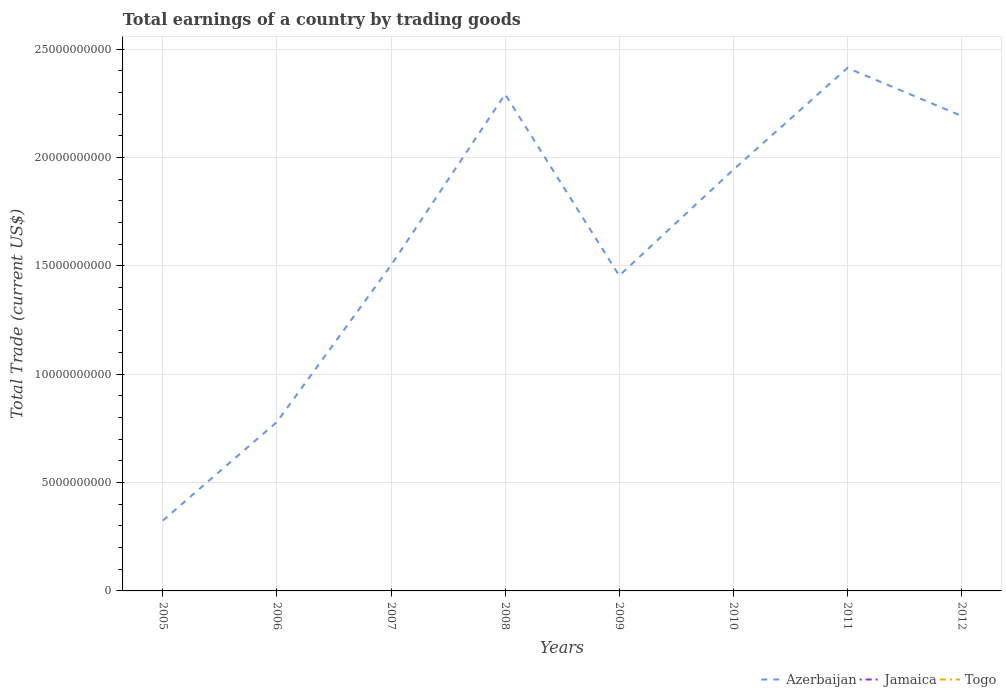How many different coloured lines are there?
Give a very brief answer. 1. Across all years, what is the maximum total earnings in Azerbaijan?
Make the answer very short. 3.25e+09. What is the total total earnings in Azerbaijan in the graph?
Keep it short and to the point. -6.75e+09. What is the difference between the highest and the second highest total earnings in Azerbaijan?
Give a very brief answer. 2.09e+1. Is the total earnings in Jamaica strictly greater than the total earnings in Azerbaijan over the years?
Your answer should be compact. Yes. How many years are there in the graph?
Ensure brevity in your answer.  8. What is the difference between two consecutive major ticks on the Y-axis?
Offer a terse response. 5.00e+09. Are the values on the major ticks of Y-axis written in scientific E-notation?
Your answer should be compact. No. Does the graph contain any zero values?
Keep it short and to the point. Yes. Where does the legend appear in the graph?
Offer a very short reply. Bottom right. How are the legend labels stacked?
Keep it short and to the point. Horizontal. What is the title of the graph?
Your response must be concise. Total earnings of a country by trading goods. What is the label or title of the Y-axis?
Your response must be concise. Total Trade (current US$). What is the Total Trade (current US$) of Azerbaijan in 2005?
Give a very brief answer. 3.25e+09. What is the Total Trade (current US$) of Jamaica in 2005?
Give a very brief answer. 0. What is the Total Trade (current US$) in Azerbaijan in 2006?
Make the answer very short. 7.80e+09. What is the Total Trade (current US$) of Jamaica in 2006?
Make the answer very short. 0. What is the Total Trade (current US$) in Azerbaijan in 2007?
Offer a terse response. 1.50e+1. What is the Total Trade (current US$) in Jamaica in 2007?
Your answer should be compact. 0. What is the Total Trade (current US$) of Azerbaijan in 2008?
Offer a very short reply. 2.29e+1. What is the Total Trade (current US$) of Togo in 2008?
Provide a short and direct response. 0. What is the Total Trade (current US$) of Azerbaijan in 2009?
Make the answer very short. 1.45e+1. What is the Total Trade (current US$) of Togo in 2009?
Offer a terse response. 0. What is the Total Trade (current US$) in Azerbaijan in 2010?
Your response must be concise. 1.94e+1. What is the Total Trade (current US$) in Togo in 2010?
Your answer should be compact. 0. What is the Total Trade (current US$) of Azerbaijan in 2011?
Your response must be concise. 2.41e+1. What is the Total Trade (current US$) in Togo in 2011?
Your response must be concise. 0. What is the Total Trade (current US$) in Azerbaijan in 2012?
Your answer should be very brief. 2.19e+1. What is the Total Trade (current US$) in Jamaica in 2012?
Your response must be concise. 0. Across all years, what is the maximum Total Trade (current US$) in Azerbaijan?
Offer a terse response. 2.41e+1. Across all years, what is the minimum Total Trade (current US$) in Azerbaijan?
Your answer should be compact. 3.25e+09. What is the total Total Trade (current US$) in Azerbaijan in the graph?
Give a very brief answer. 1.29e+11. What is the difference between the Total Trade (current US$) in Azerbaijan in 2005 and that in 2006?
Make the answer very short. -4.55e+09. What is the difference between the Total Trade (current US$) of Azerbaijan in 2005 and that in 2007?
Your response must be concise. -1.18e+1. What is the difference between the Total Trade (current US$) of Azerbaijan in 2005 and that in 2008?
Your answer should be compact. -1.97e+1. What is the difference between the Total Trade (current US$) in Azerbaijan in 2005 and that in 2009?
Ensure brevity in your answer.  -1.13e+1. What is the difference between the Total Trade (current US$) in Azerbaijan in 2005 and that in 2010?
Provide a succinct answer. -1.62e+1. What is the difference between the Total Trade (current US$) of Azerbaijan in 2005 and that in 2011?
Your answer should be compact. -2.09e+1. What is the difference between the Total Trade (current US$) in Azerbaijan in 2005 and that in 2012?
Your response must be concise. -1.87e+1. What is the difference between the Total Trade (current US$) in Azerbaijan in 2006 and that in 2007?
Ensure brevity in your answer.  -7.23e+09. What is the difference between the Total Trade (current US$) of Azerbaijan in 2006 and that in 2008?
Provide a succinct answer. -1.51e+1. What is the difference between the Total Trade (current US$) of Azerbaijan in 2006 and that in 2009?
Provide a short and direct response. -6.75e+09. What is the difference between the Total Trade (current US$) of Azerbaijan in 2006 and that in 2010?
Keep it short and to the point. -1.16e+1. What is the difference between the Total Trade (current US$) of Azerbaijan in 2006 and that in 2011?
Your answer should be very brief. -1.63e+1. What is the difference between the Total Trade (current US$) in Azerbaijan in 2006 and that in 2012?
Provide a short and direct response. -1.41e+1. What is the difference between the Total Trade (current US$) in Azerbaijan in 2007 and that in 2008?
Your answer should be compact. -7.89e+09. What is the difference between the Total Trade (current US$) of Azerbaijan in 2007 and that in 2009?
Offer a terse response. 4.78e+08. What is the difference between the Total Trade (current US$) of Azerbaijan in 2007 and that in 2010?
Your answer should be compact. -4.41e+09. What is the difference between the Total Trade (current US$) of Azerbaijan in 2007 and that in 2011?
Your answer should be compact. -9.11e+09. What is the difference between the Total Trade (current US$) of Azerbaijan in 2007 and that in 2012?
Your answer should be very brief. -6.89e+09. What is the difference between the Total Trade (current US$) in Azerbaijan in 2008 and that in 2009?
Your response must be concise. 8.37e+09. What is the difference between the Total Trade (current US$) of Azerbaijan in 2008 and that in 2010?
Keep it short and to the point. 3.48e+09. What is the difference between the Total Trade (current US$) in Azerbaijan in 2008 and that in 2011?
Give a very brief answer. -1.21e+09. What is the difference between the Total Trade (current US$) in Azerbaijan in 2008 and that in 2012?
Your response must be concise. 1.00e+09. What is the difference between the Total Trade (current US$) in Azerbaijan in 2009 and that in 2010?
Provide a short and direct response. -4.89e+09. What is the difference between the Total Trade (current US$) of Azerbaijan in 2009 and that in 2011?
Ensure brevity in your answer.  -9.58e+09. What is the difference between the Total Trade (current US$) in Azerbaijan in 2009 and that in 2012?
Your response must be concise. -7.37e+09. What is the difference between the Total Trade (current US$) in Azerbaijan in 2010 and that in 2011?
Your response must be concise. -4.69e+09. What is the difference between the Total Trade (current US$) of Azerbaijan in 2010 and that in 2012?
Give a very brief answer. -2.48e+09. What is the difference between the Total Trade (current US$) in Azerbaijan in 2011 and that in 2012?
Your answer should be very brief. 2.21e+09. What is the average Total Trade (current US$) of Azerbaijan per year?
Offer a very short reply. 1.61e+1. What is the average Total Trade (current US$) in Togo per year?
Provide a succinct answer. 0. What is the ratio of the Total Trade (current US$) of Azerbaijan in 2005 to that in 2006?
Provide a succinct answer. 0.42. What is the ratio of the Total Trade (current US$) of Azerbaijan in 2005 to that in 2007?
Your response must be concise. 0.22. What is the ratio of the Total Trade (current US$) in Azerbaijan in 2005 to that in 2008?
Your answer should be compact. 0.14. What is the ratio of the Total Trade (current US$) in Azerbaijan in 2005 to that in 2009?
Keep it short and to the point. 0.22. What is the ratio of the Total Trade (current US$) in Azerbaijan in 2005 to that in 2010?
Provide a short and direct response. 0.17. What is the ratio of the Total Trade (current US$) in Azerbaijan in 2005 to that in 2011?
Offer a very short reply. 0.13. What is the ratio of the Total Trade (current US$) of Azerbaijan in 2005 to that in 2012?
Make the answer very short. 0.15. What is the ratio of the Total Trade (current US$) in Azerbaijan in 2006 to that in 2007?
Your answer should be compact. 0.52. What is the ratio of the Total Trade (current US$) in Azerbaijan in 2006 to that in 2008?
Provide a short and direct response. 0.34. What is the ratio of the Total Trade (current US$) in Azerbaijan in 2006 to that in 2009?
Your response must be concise. 0.54. What is the ratio of the Total Trade (current US$) of Azerbaijan in 2006 to that in 2010?
Offer a terse response. 0.4. What is the ratio of the Total Trade (current US$) in Azerbaijan in 2006 to that in 2011?
Your answer should be very brief. 0.32. What is the ratio of the Total Trade (current US$) in Azerbaijan in 2006 to that in 2012?
Offer a very short reply. 0.36. What is the ratio of the Total Trade (current US$) in Azerbaijan in 2007 to that in 2008?
Your answer should be very brief. 0.66. What is the ratio of the Total Trade (current US$) of Azerbaijan in 2007 to that in 2009?
Ensure brevity in your answer.  1.03. What is the ratio of the Total Trade (current US$) of Azerbaijan in 2007 to that in 2010?
Offer a terse response. 0.77. What is the ratio of the Total Trade (current US$) of Azerbaijan in 2007 to that in 2011?
Keep it short and to the point. 0.62. What is the ratio of the Total Trade (current US$) of Azerbaijan in 2007 to that in 2012?
Provide a succinct answer. 0.69. What is the ratio of the Total Trade (current US$) in Azerbaijan in 2008 to that in 2009?
Your answer should be very brief. 1.58. What is the ratio of the Total Trade (current US$) of Azerbaijan in 2008 to that in 2010?
Provide a succinct answer. 1.18. What is the ratio of the Total Trade (current US$) of Azerbaijan in 2008 to that in 2011?
Make the answer very short. 0.95. What is the ratio of the Total Trade (current US$) of Azerbaijan in 2008 to that in 2012?
Provide a short and direct response. 1.05. What is the ratio of the Total Trade (current US$) of Azerbaijan in 2009 to that in 2010?
Provide a succinct answer. 0.75. What is the ratio of the Total Trade (current US$) of Azerbaijan in 2009 to that in 2011?
Your answer should be very brief. 0.6. What is the ratio of the Total Trade (current US$) of Azerbaijan in 2009 to that in 2012?
Ensure brevity in your answer.  0.66. What is the ratio of the Total Trade (current US$) of Azerbaijan in 2010 to that in 2011?
Offer a very short reply. 0.81. What is the ratio of the Total Trade (current US$) of Azerbaijan in 2010 to that in 2012?
Provide a short and direct response. 0.89. What is the ratio of the Total Trade (current US$) in Azerbaijan in 2011 to that in 2012?
Provide a succinct answer. 1.1. What is the difference between the highest and the second highest Total Trade (current US$) in Azerbaijan?
Your answer should be compact. 1.21e+09. What is the difference between the highest and the lowest Total Trade (current US$) in Azerbaijan?
Ensure brevity in your answer.  2.09e+1. 